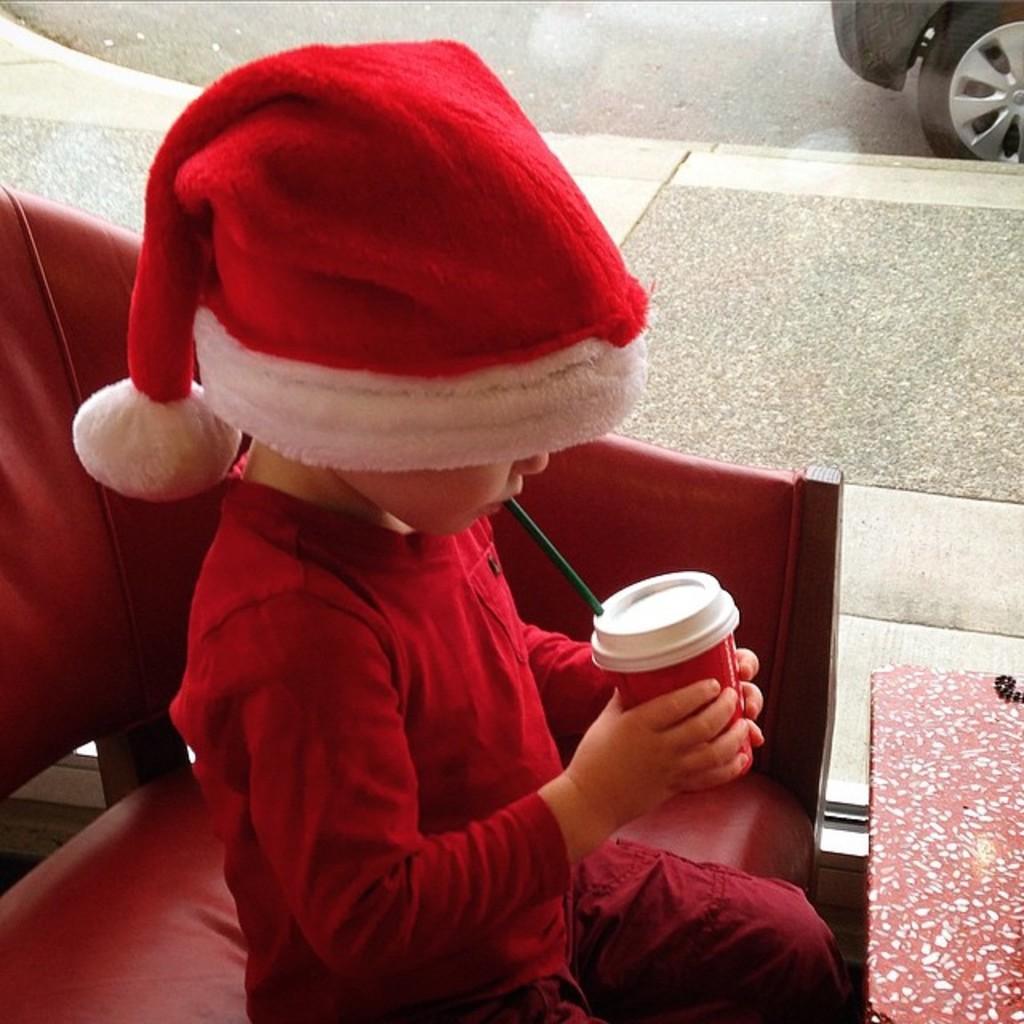Please provide a concise description of this image. In this image we can see a person sitting on the chair. A person is drinking some drink. There is a table at the bottom right most of the image. There is a vehicle at the top right most of the image. 